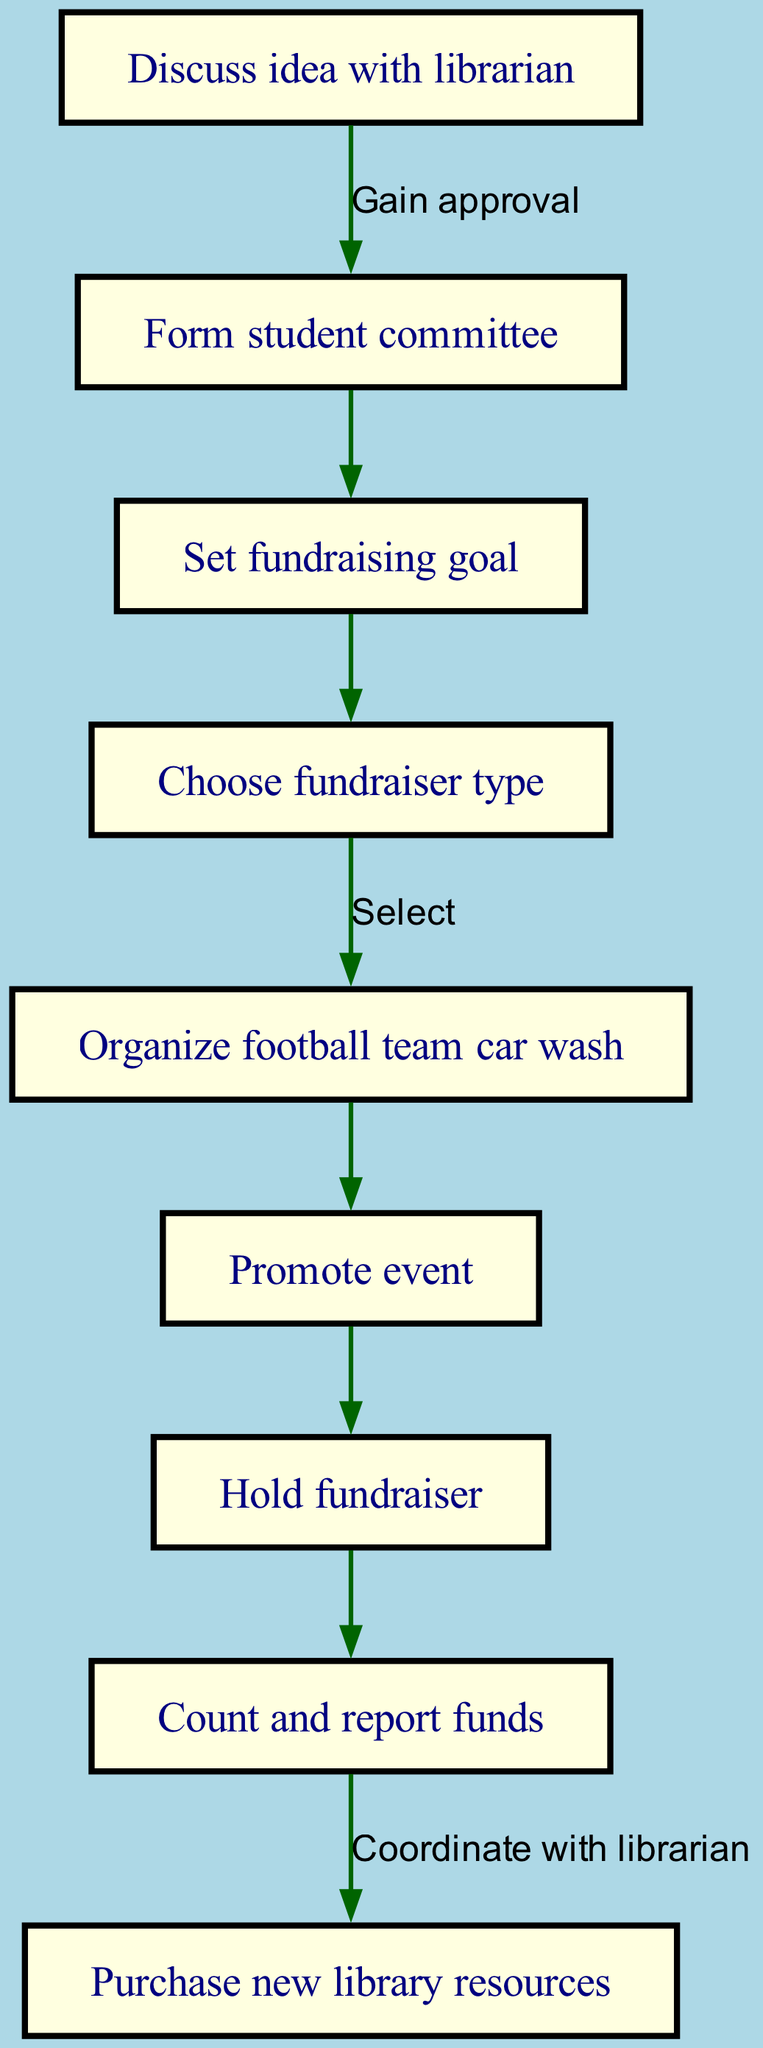What is the first step in the process? The first step is to "Discuss idea with librarian," which is the starting point of the flow chart.
Answer: Discuss idea with librarian How many nodes are in the diagram? By counting the distinct steps listed, there are 9 nodes, each representing a step in the fundraiser process.
Answer: 9 What is the final action taken at the end of the flow chart? The final action in the process is to "Purchase new library resources," as indicated by the last node in the flow.
Answer: Purchase new library resources What follows the "Choose fundraiser type" step? After "Choose fundraiser type," the next step is "Organize football team car wash," indicating what action is decided.
Answer: Organize football team car wash How does one progress from holding the fundraiser to reporting funds? After the "Hold fundraiser" step, the process moves directly to "Count and report funds," which is the next logical step following the event.
Answer: Count and report funds What is required after "Discuss idea with librarian"? The required action after "Discuss idea with librarian" is to "Form student committee," which shows the necessary approval flow.
Answer: Form student committee Which step involves promoting the event? The step that involves promoting the event is "Promote event," which indicates the campaign phase of the fundraiser.
Answer: Promote event What action must be taken after counting funds? After counting the funds, the next action is to "Purchase new library resources," marking the utilization of the raised funds.
Answer: Purchase new library resources How many edges link the nodes? There are 8 edges in the diagram, which connect the different steps in the flow of organizing the fundraiser.
Answer: 8 